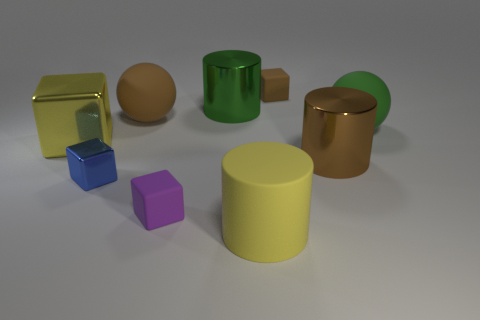Could you tell me which object stands out the most and why? The yellow cylinder stands out due to its vibrant color and central placement in the image, drawing the viewer's eye as a focal point. 